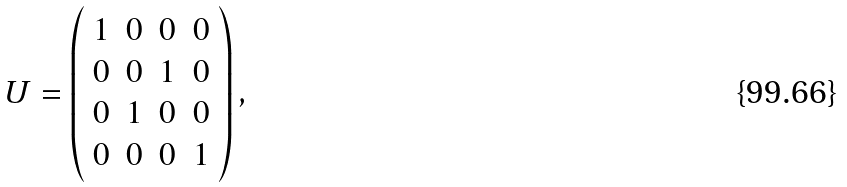Convert formula to latex. <formula><loc_0><loc_0><loc_500><loc_500>U = \left ( \begin{array} { c c c c } { 1 } & { 0 } & { 0 } & { 0 } \\ { 0 } & { 0 } & { 1 } & { 0 } \\ { 0 } & { 1 } & { 0 } & { 0 } \\ { 0 } & { 0 } & { 0 } & { 1 } \end{array} \right ) ,</formula> 